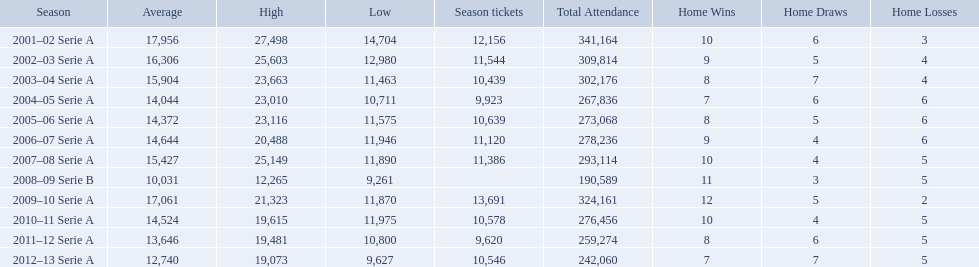What are the seasons? 2001–02 Serie A, 2002–03 Serie A, 2003–04 Serie A, 2004–05 Serie A, 2005–06 Serie A, 2006–07 Serie A, 2007–08 Serie A, 2008–09 Serie B, 2009–10 Serie A, 2010–11 Serie A, 2011–12 Serie A, 2012–13 Serie A. Which season is in 2007? 2007–08 Serie A. How many season tickets were sold that season? 11,386. 